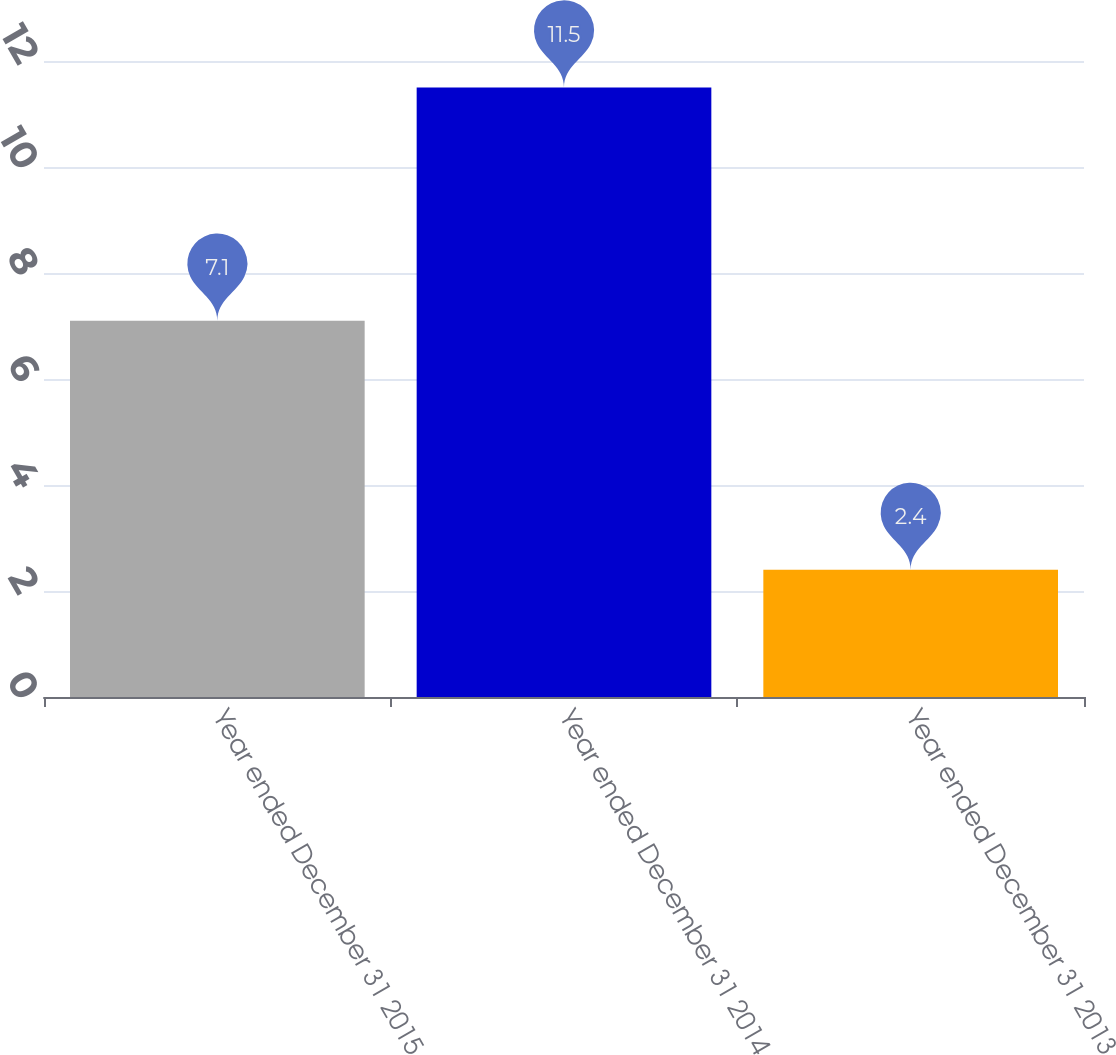Convert chart. <chart><loc_0><loc_0><loc_500><loc_500><bar_chart><fcel>Year ended December 31 2015<fcel>Year ended December 31 2014<fcel>Year ended December 31 2013<nl><fcel>7.1<fcel>11.5<fcel>2.4<nl></chart> 